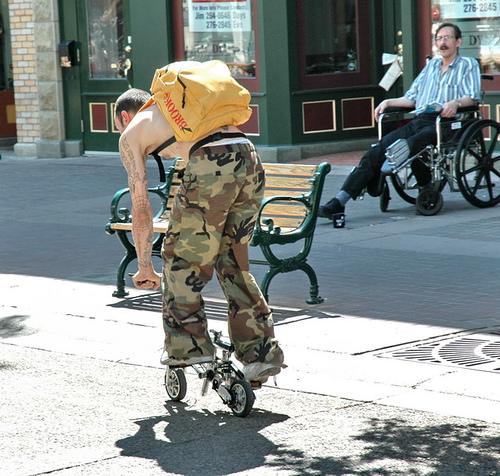Where is the wheelchair?
Give a very brief answer. Background. Is it a hot day?
Short answer required. Yes. Is the man riding the tiny bike wearing a shirt?
Quick response, please. No. 